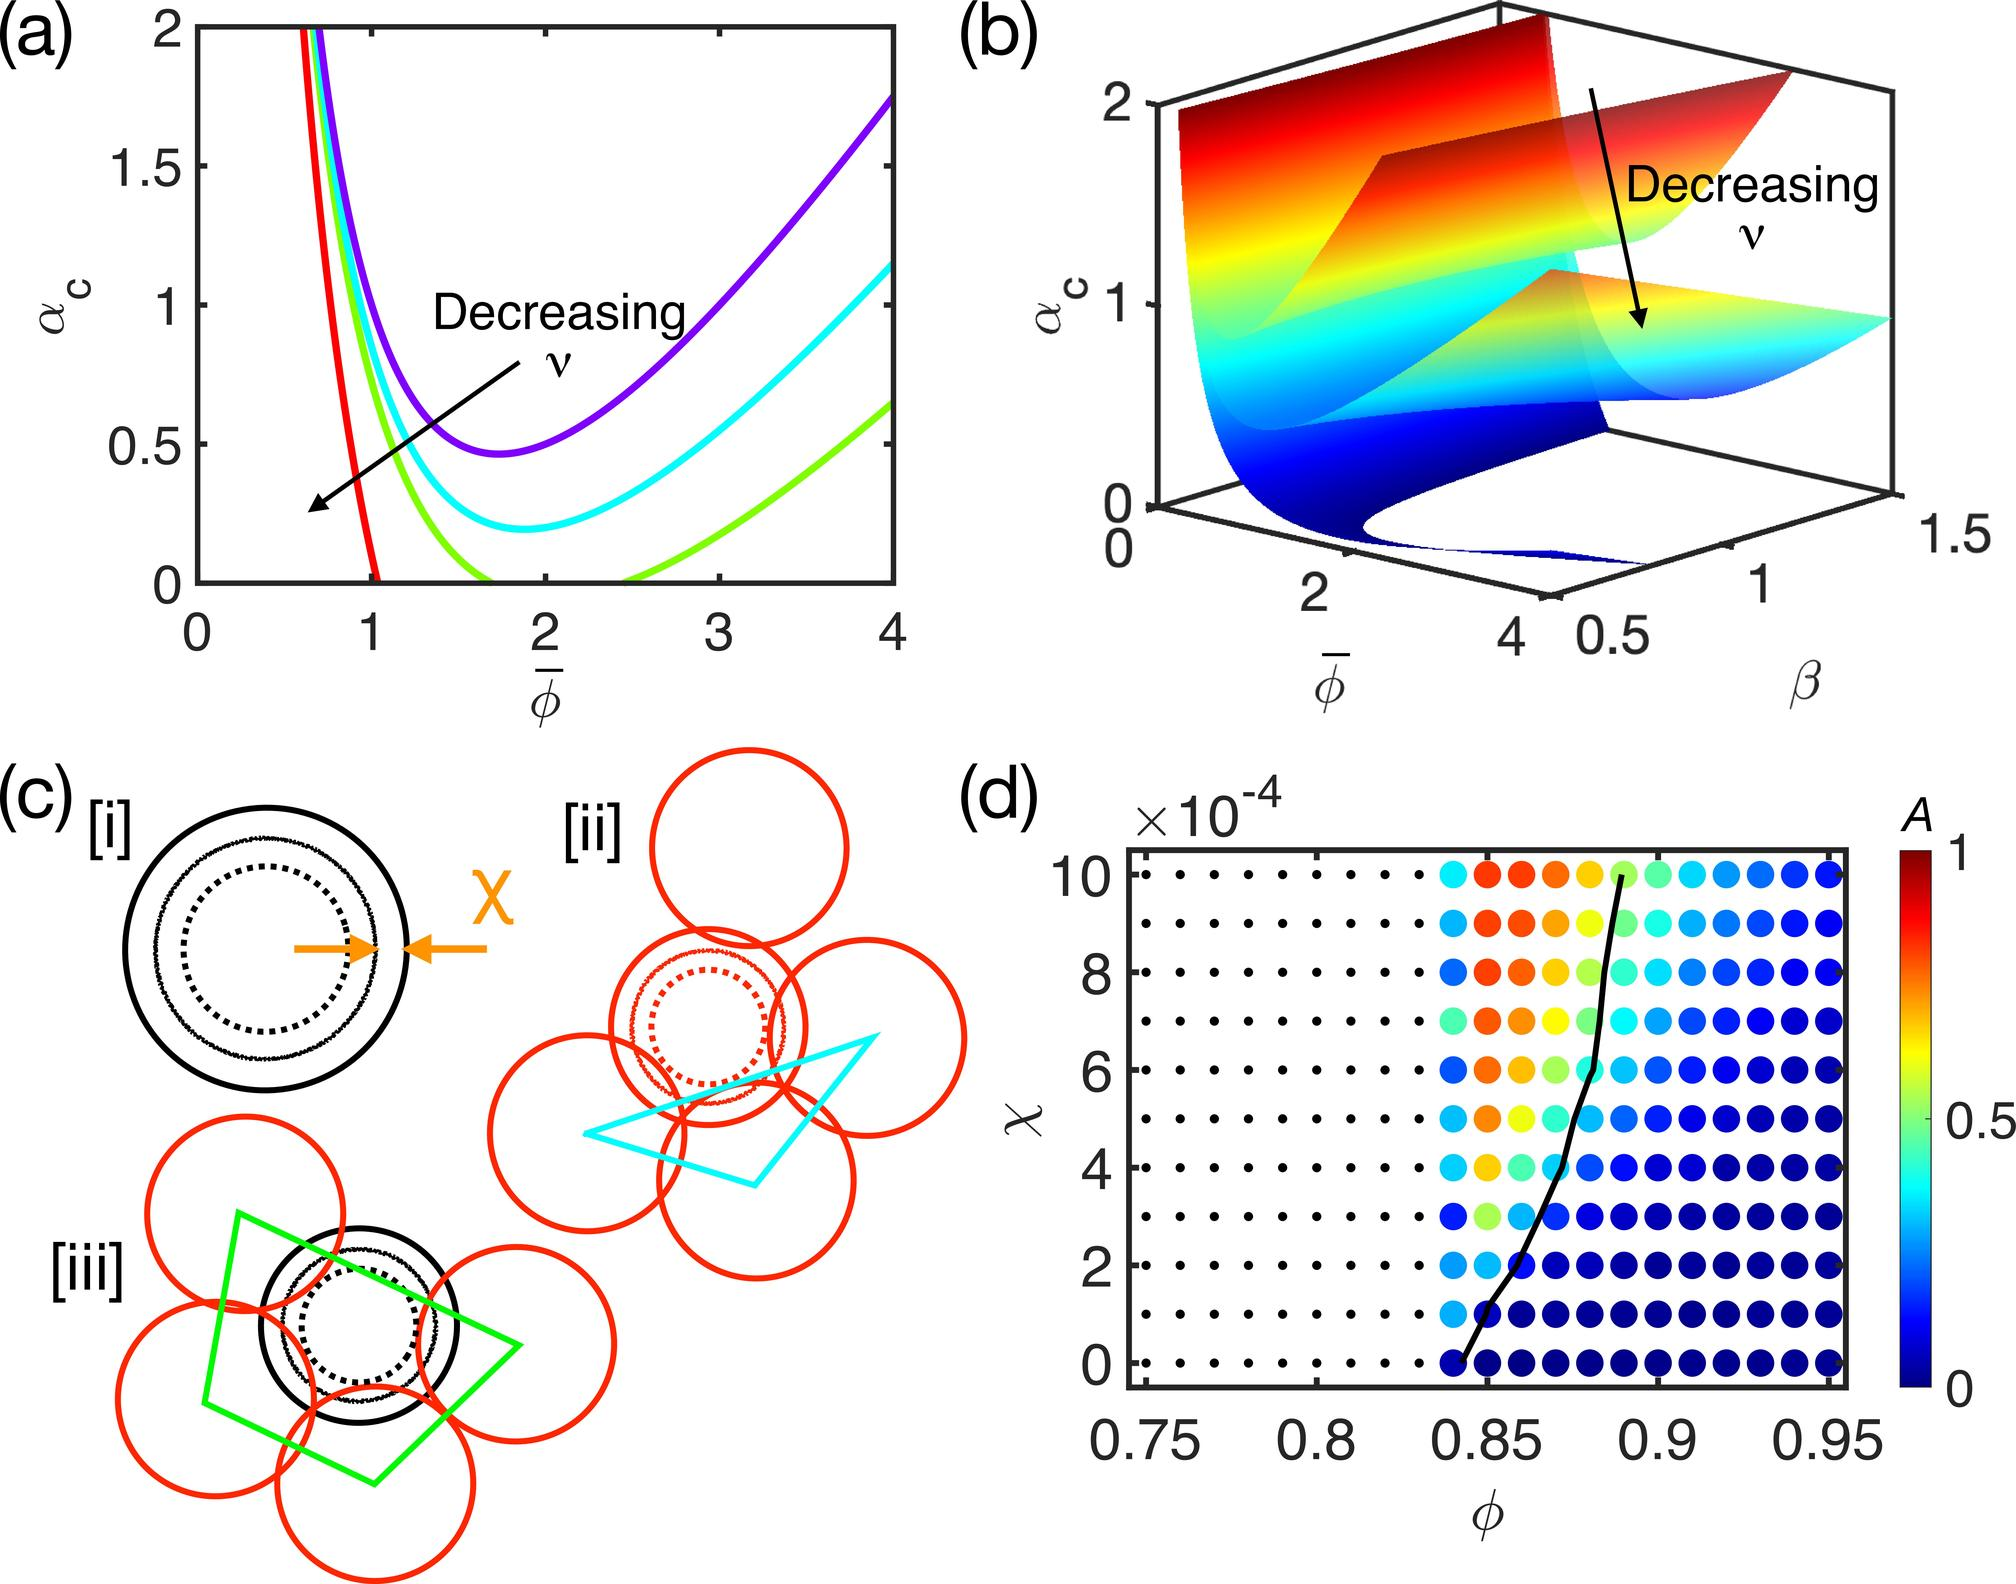Can you explain what might cause the complexities in the relationship between \\phi and A as indicated by the color gradient in the image? The complexities in the relationship between \(\phi\) and A, as visualized by the color gradient, could be driven by various factors including the influence of other variables not immediately visible on the graph, or non-linear dynamics inherent to the phenomenon being studied. The color variation indicates that as \(\phi\) increases or decreases, A's behavior changes in a non-uniform manner. This could suggest that A is sensitive to threshold effects or has a conditional dependence on another parameter, such as \(\beta\), manifesting in the observed complex pattern. 